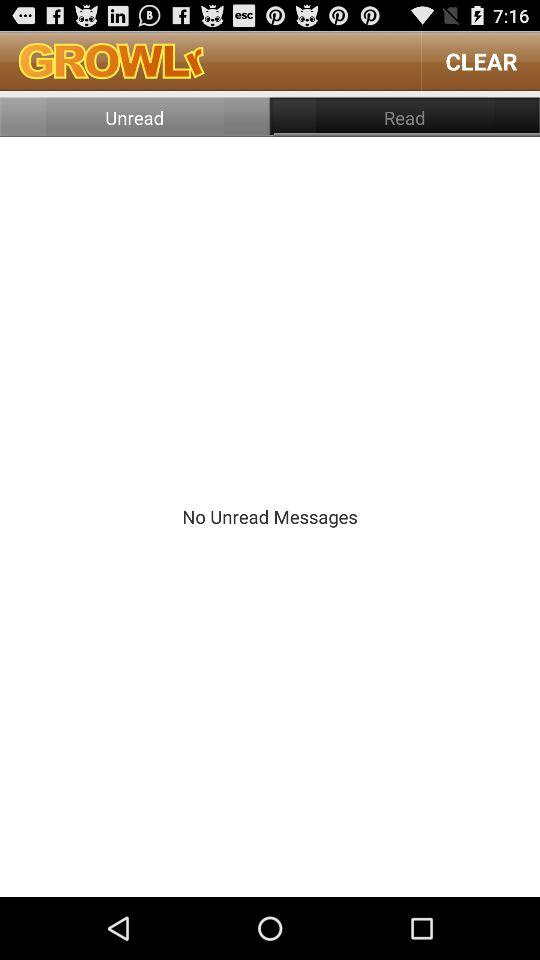Is there any unread message? There is no unread message. 